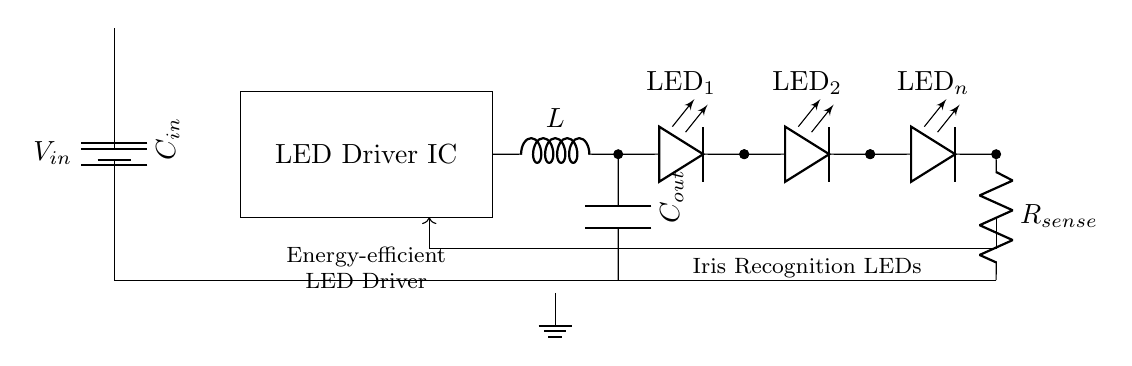What component regulates the LED current? The feedback loop in the circuit, coming from the current sense resistor, helps regulate the current through the LED string, ensuring they operate efficiently.
Answer: LED Driver IC What is the role of the inductor in this circuit? The inductor stores energy and helps in maintaining a steady current through the LED string by smoothing out current fluctuations, which is essential for energy efficiency.
Answer: Energy storage How many LEDs are shown in the circuit diagram? By counting the labeled LED components in the circuit, we identify three LEDs: LED one, LED two, and LED n.
Answer: Three What is connected between the output of the LED driver IC and the LED string? The output of the LED driver IC is connected to the inductor, which then connects to the output capacitor and the LED string for energy-efficient power delivery.
Answer: Inductor What is the function of the sense resistor in the circuit? The sense resistor measures the current flowing through the LED string, providing feedback for the driver IC to adjust its output, ensuring optimal efficiency and performance.
Answer: Current sensing What type of circuit is represented in this schematic? The circuit is specifically designed as an LED driver circuit focusing on energy efficiency, particularly for applications such as iris recognition systems which require precise illumination control.
Answer: LED driver circuit 